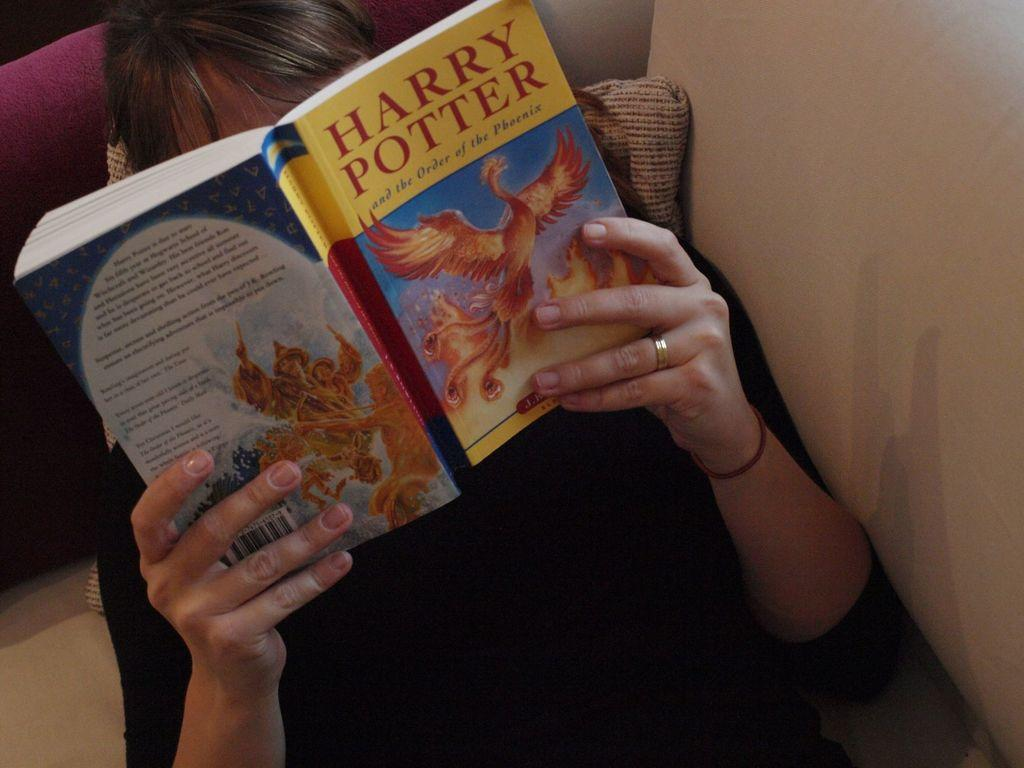<image>
Describe the image concisely. A woman reading a coppy of "Harry Potter and the order of the Phoenix". 